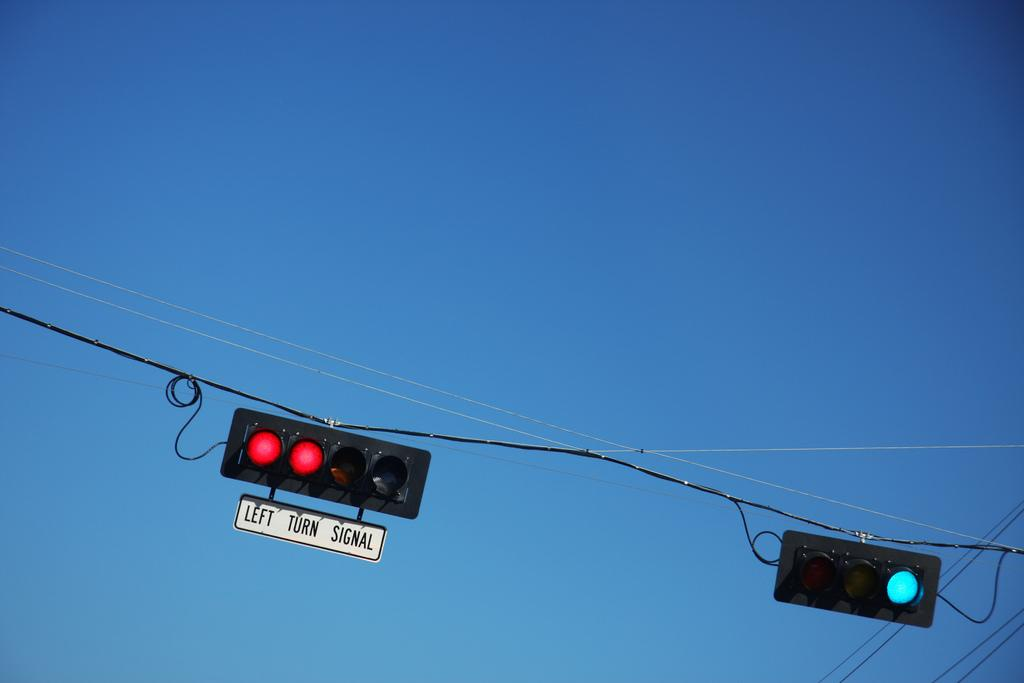<image>
Render a clear and concise summary of the photo. Two traffic lights strung up in the sky with a left turn signal attached to the left one. 